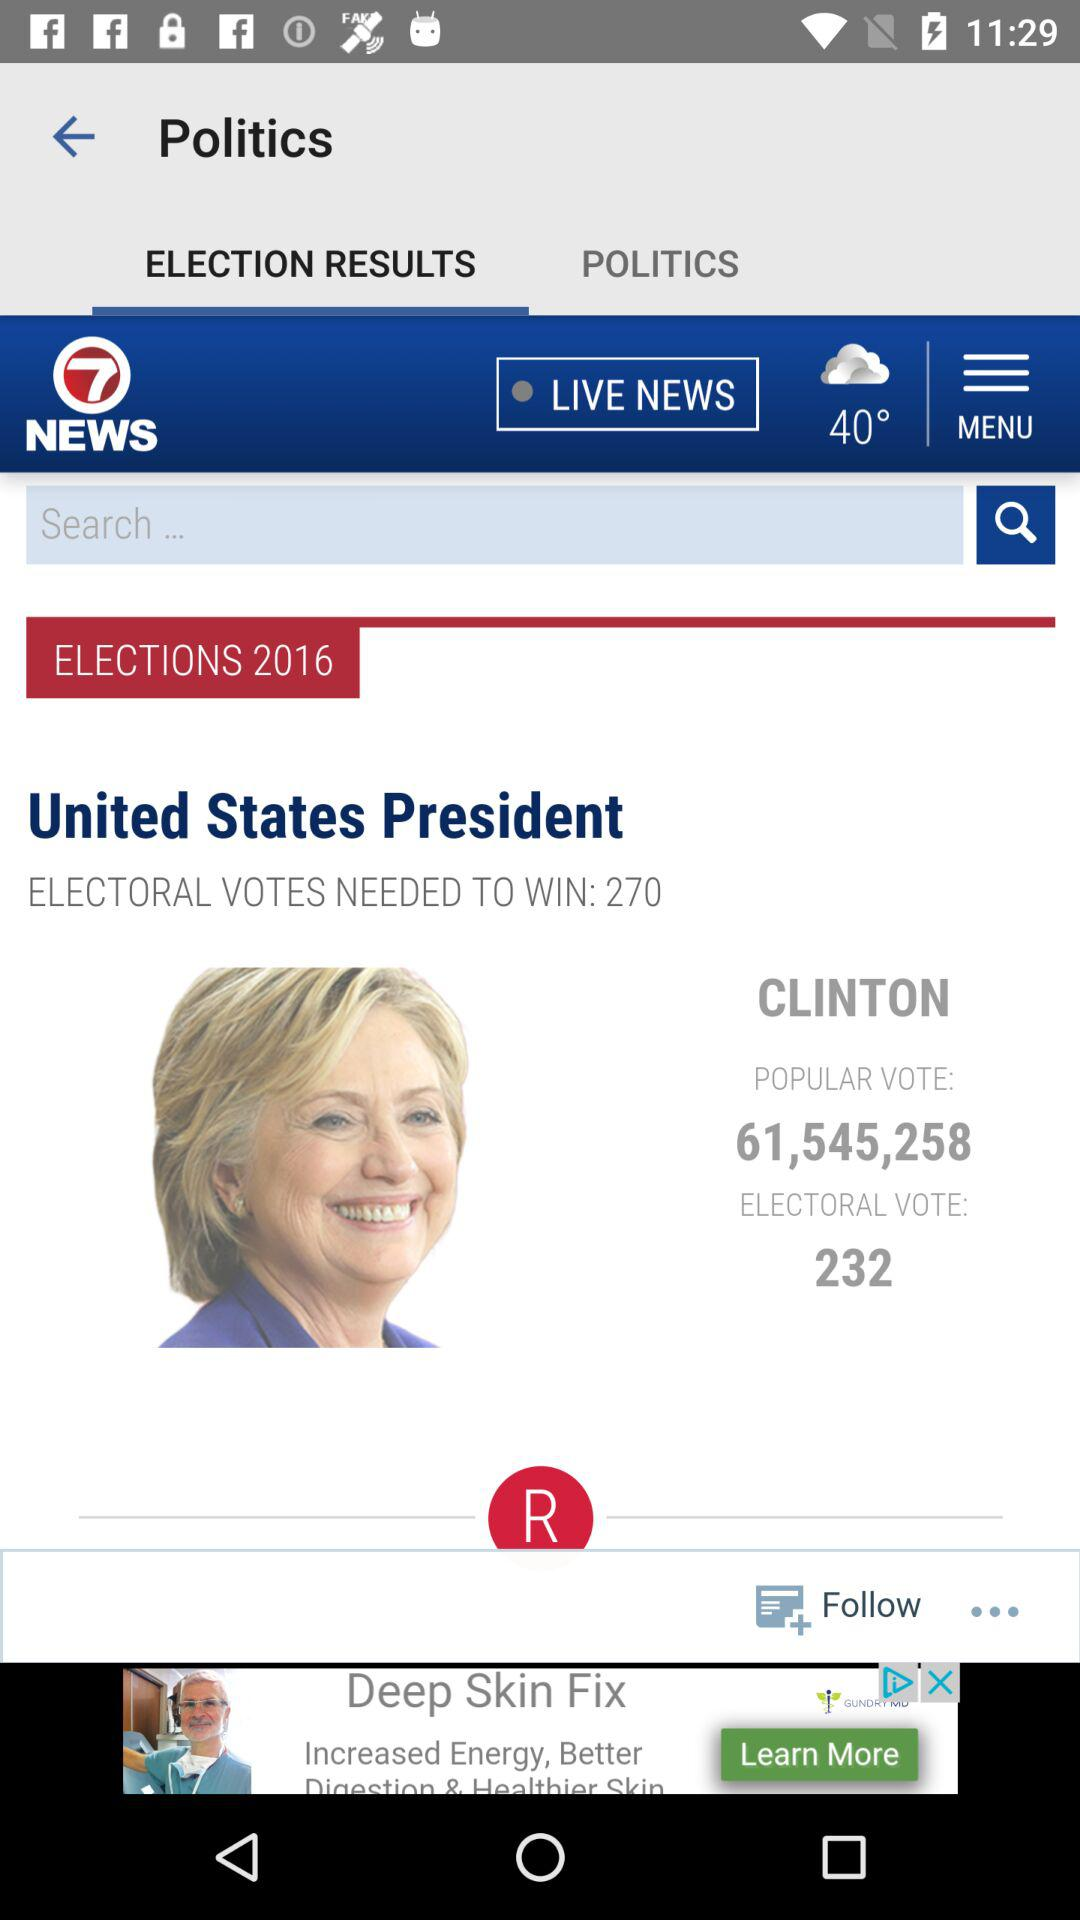What is the temperature? The temperature is 40°. 